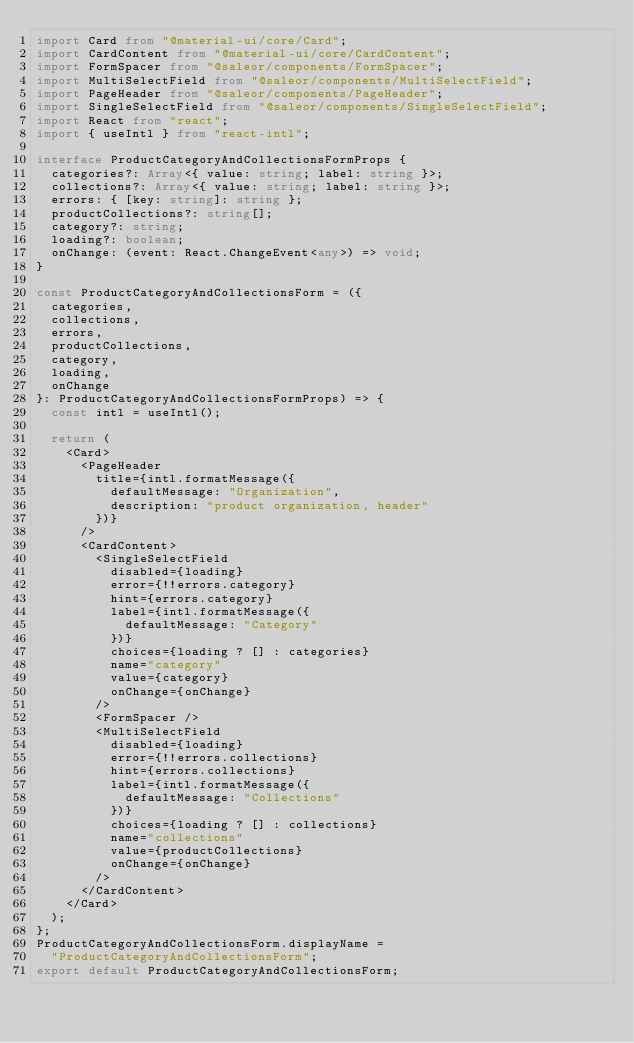Convert code to text. <code><loc_0><loc_0><loc_500><loc_500><_TypeScript_>import Card from "@material-ui/core/Card";
import CardContent from "@material-ui/core/CardContent";
import FormSpacer from "@saleor/components/FormSpacer";
import MultiSelectField from "@saleor/components/MultiSelectField";
import PageHeader from "@saleor/components/PageHeader";
import SingleSelectField from "@saleor/components/SingleSelectField";
import React from "react";
import { useIntl } from "react-intl";

interface ProductCategoryAndCollectionsFormProps {
  categories?: Array<{ value: string; label: string }>;
  collections?: Array<{ value: string; label: string }>;
  errors: { [key: string]: string };
  productCollections?: string[];
  category?: string;
  loading?: boolean;
  onChange: (event: React.ChangeEvent<any>) => void;
}

const ProductCategoryAndCollectionsForm = ({
  categories,
  collections,
  errors,
  productCollections,
  category,
  loading,
  onChange
}: ProductCategoryAndCollectionsFormProps) => {
  const intl = useIntl();

  return (
    <Card>
      <PageHeader
        title={intl.formatMessage({
          defaultMessage: "Organization",
          description: "product organization, header"
        })}
      />
      <CardContent>
        <SingleSelectField
          disabled={loading}
          error={!!errors.category}
          hint={errors.category}
          label={intl.formatMessage({
            defaultMessage: "Category"
          })}
          choices={loading ? [] : categories}
          name="category"
          value={category}
          onChange={onChange}
        />
        <FormSpacer />
        <MultiSelectField
          disabled={loading}
          error={!!errors.collections}
          hint={errors.collections}
          label={intl.formatMessage({
            defaultMessage: "Collections"
          })}
          choices={loading ? [] : collections}
          name="collections"
          value={productCollections}
          onChange={onChange}
        />
      </CardContent>
    </Card>
  );
};
ProductCategoryAndCollectionsForm.displayName =
  "ProductCategoryAndCollectionsForm";
export default ProductCategoryAndCollectionsForm;
</code> 